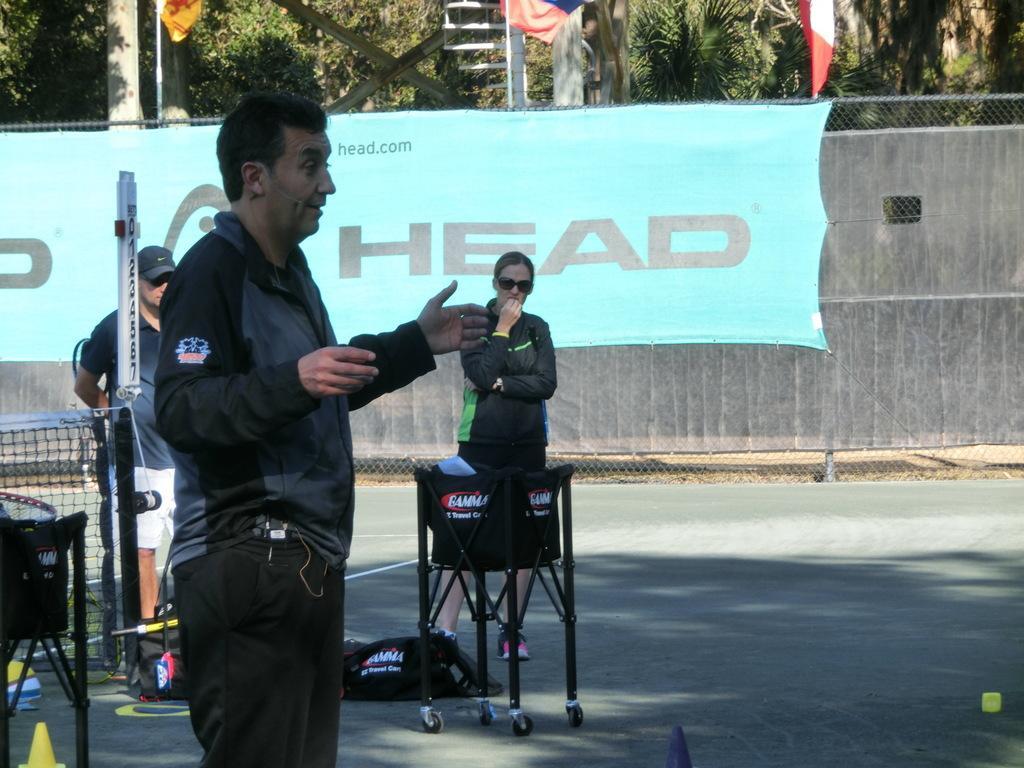Please provide a concise description of this image. A man is standing, here people are standing on the road, this is net, here there are trees, this is banner. 